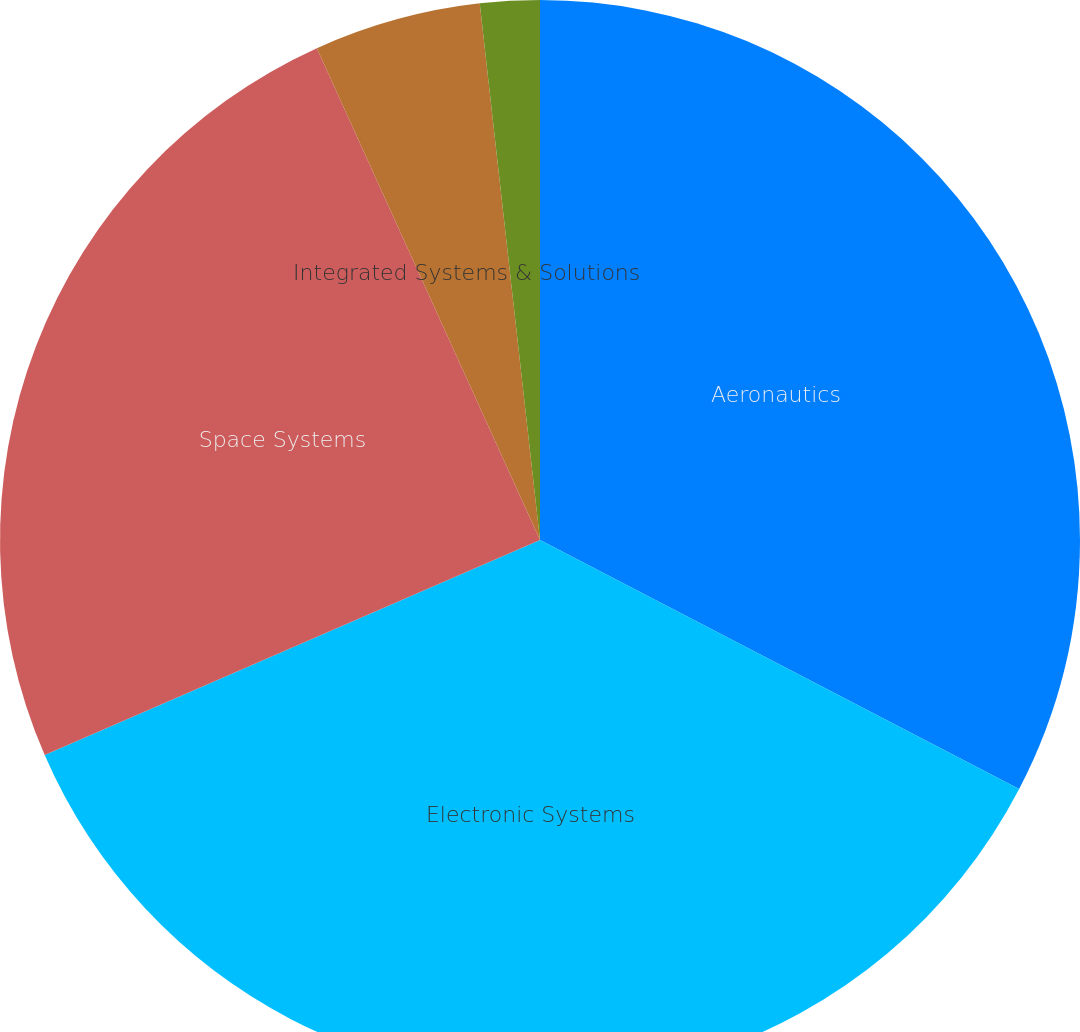<chart> <loc_0><loc_0><loc_500><loc_500><pie_chart><fcel>Aeronautics<fcel>Electronic Systems<fcel>Space Systems<fcel>Integrated Systems & Solutions<fcel>Information & Technology<nl><fcel>32.63%<fcel>35.85%<fcel>24.74%<fcel>5.0%<fcel>1.78%<nl></chart> 